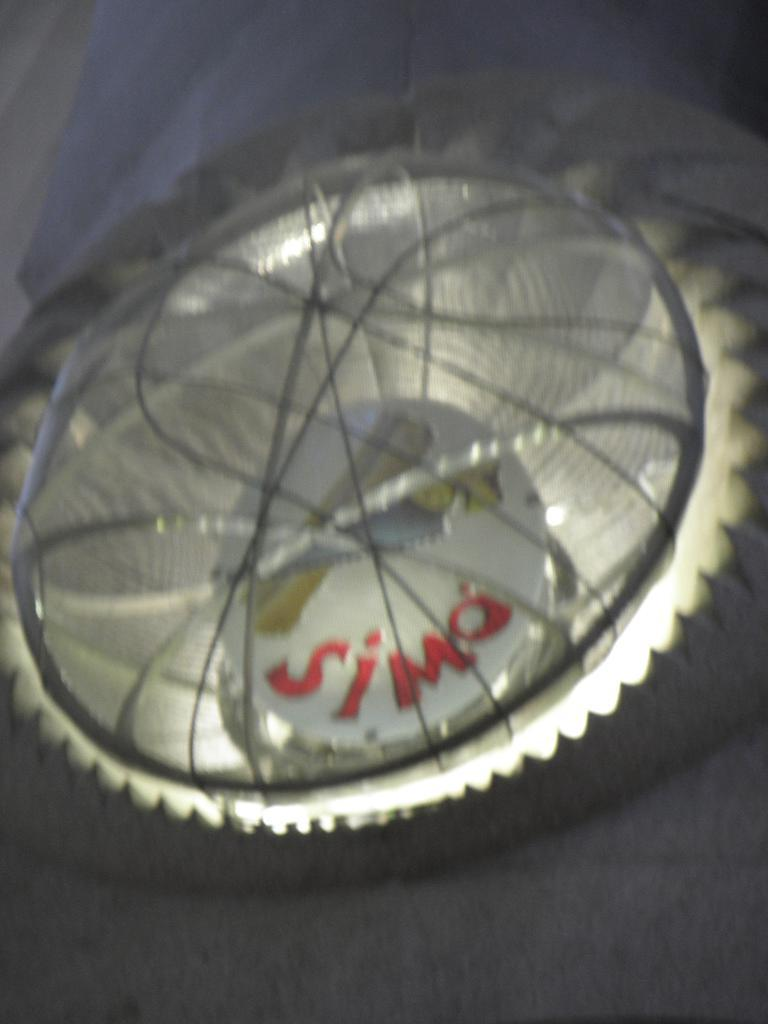What shape can be seen on the building in the image? There is a circle on the building in the image. What object is also present on the building? There is a ball on the building in the image. What can be seen emanating from the building? Lights beams are visible in the image. What type of flame can be seen coming out of the ball in the image? There is no flame present in the image; it features a circle and a ball on a building with lights beams. What type of skirt is visible on the building in the image? There is no skirt present in the image; it features a circle, a ball, and lights beams on a building. 